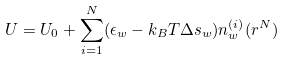Convert formula to latex. <formula><loc_0><loc_0><loc_500><loc_500>U = U _ { 0 } + \sum _ { i = 1 } ^ { N } ( \epsilon _ { w } - k _ { B } T \Delta s _ { w } ) n _ { w } ^ { ( i ) } ( r ^ { N } )</formula> 